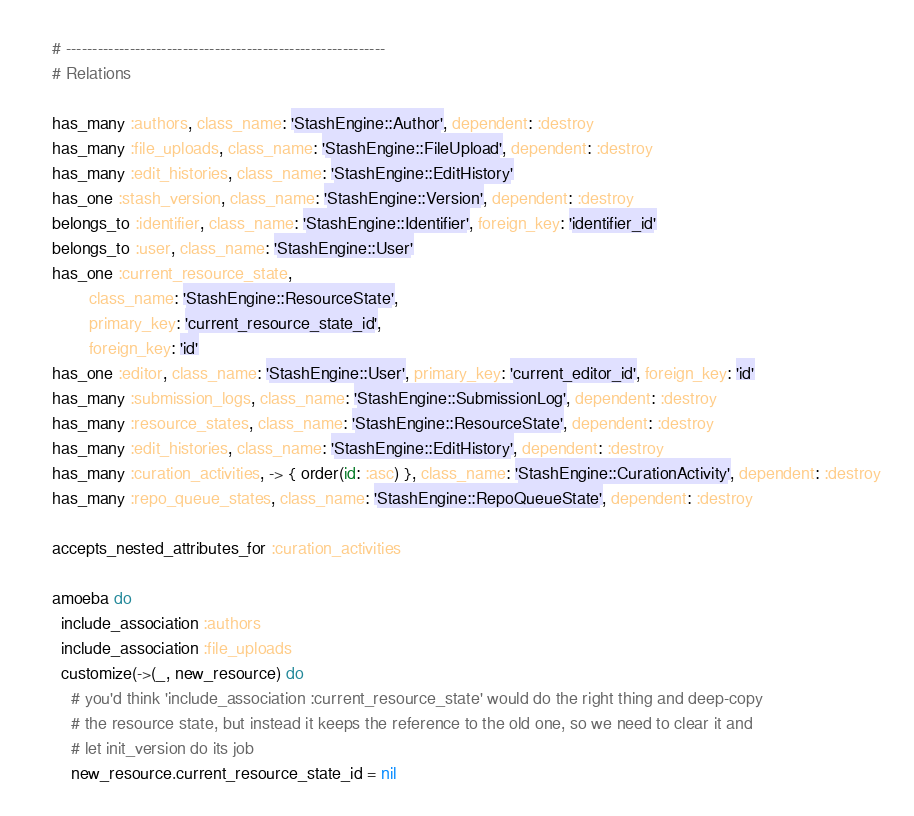<code> <loc_0><loc_0><loc_500><loc_500><_Ruby_>    # ------------------------------------------------------------
    # Relations

    has_many :authors, class_name: 'StashEngine::Author', dependent: :destroy
    has_many :file_uploads, class_name: 'StashEngine::FileUpload', dependent: :destroy
    has_many :edit_histories, class_name: 'StashEngine::EditHistory'
    has_one :stash_version, class_name: 'StashEngine::Version', dependent: :destroy
    belongs_to :identifier, class_name: 'StashEngine::Identifier', foreign_key: 'identifier_id'
    belongs_to :user, class_name: 'StashEngine::User'
    has_one :current_resource_state,
            class_name: 'StashEngine::ResourceState',
            primary_key: 'current_resource_state_id',
            foreign_key: 'id'
    has_one :editor, class_name: 'StashEngine::User', primary_key: 'current_editor_id', foreign_key: 'id'
    has_many :submission_logs, class_name: 'StashEngine::SubmissionLog', dependent: :destroy
    has_many :resource_states, class_name: 'StashEngine::ResourceState', dependent: :destroy
    has_many :edit_histories, class_name: 'StashEngine::EditHistory', dependent: :destroy
    has_many :curation_activities, -> { order(id: :asc) }, class_name: 'StashEngine::CurationActivity', dependent: :destroy
    has_many :repo_queue_states, class_name: 'StashEngine::RepoQueueState', dependent: :destroy

    accepts_nested_attributes_for :curation_activities

    amoeba do
      include_association :authors
      include_association :file_uploads
      customize(->(_, new_resource) do
        # you'd think 'include_association :current_resource_state' would do the right thing and deep-copy
        # the resource state, but instead it keeps the reference to the old one, so we need to clear it and
        # let init_version do its job
        new_resource.current_resource_state_id = nil</code> 